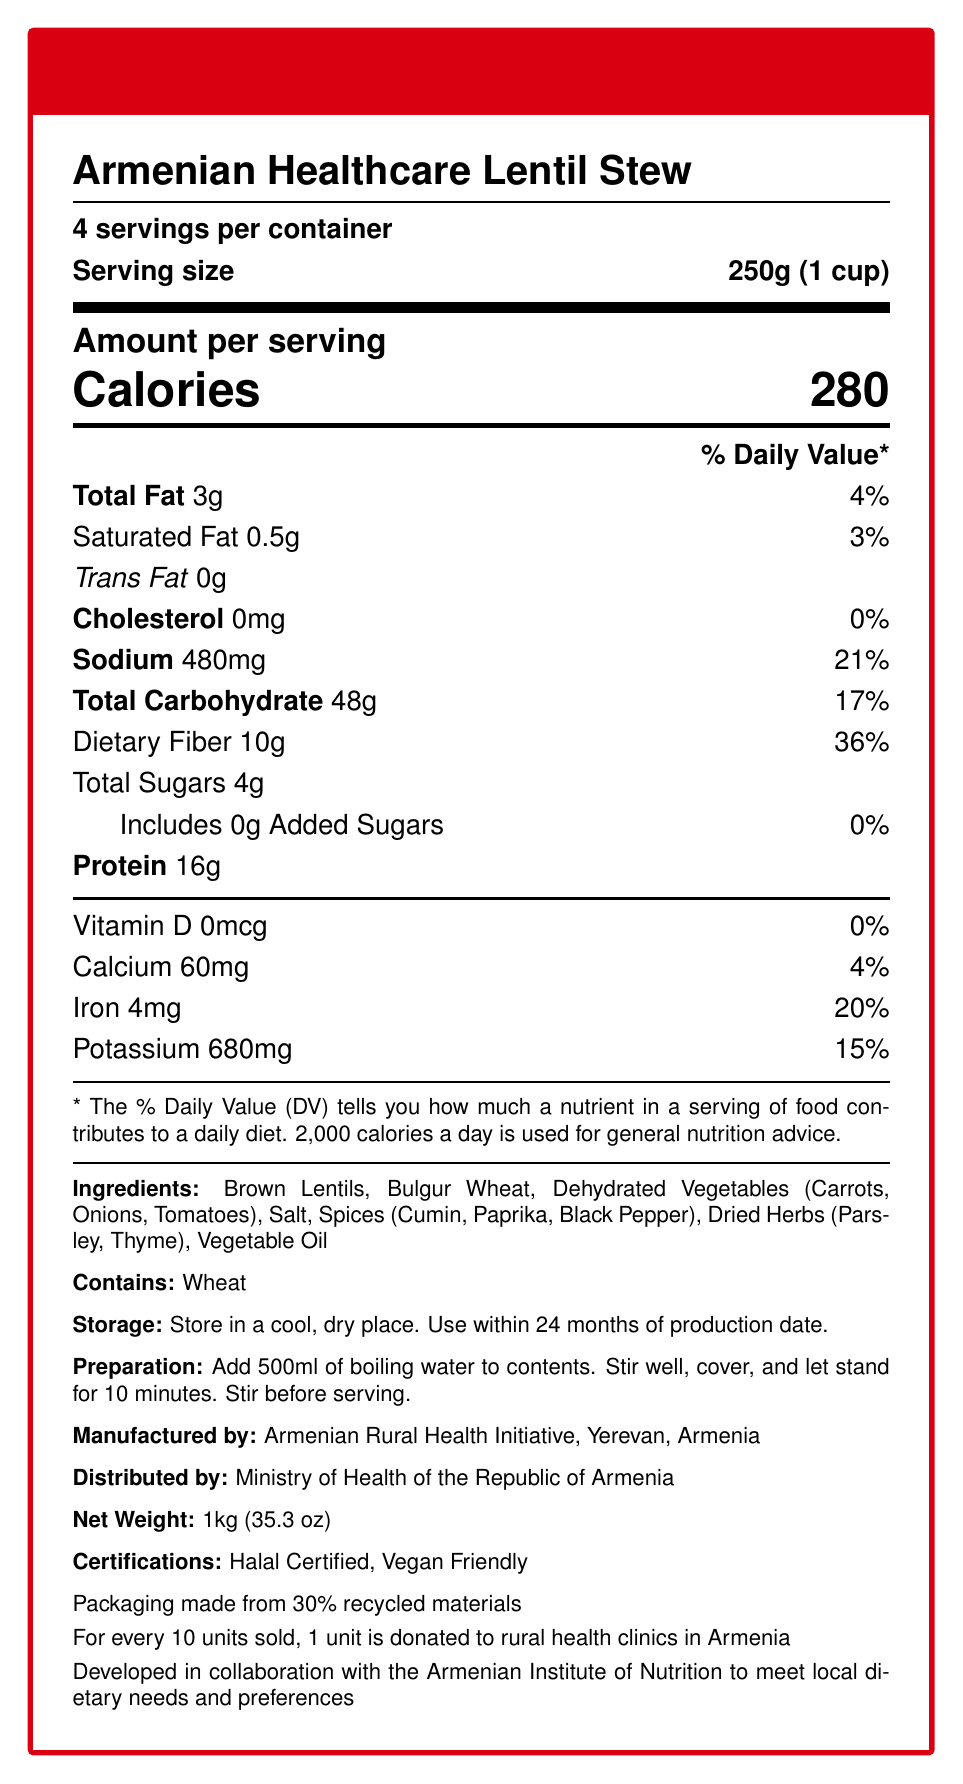what is the serving size? The serving size is specified as 250g, which is equivalent to 1 cup.
Answer: 250g (1 cup) how many servings are in a container? The document specifies that there are 4 servings per container.
Answer: 4 servings what is the amount of sodium per serving? The amount of sodium per serving is explicitly mentioned as 480mg.
Answer: 480mg how long should you let the meal stand after adding boiling water? The preparation instructions state to let the meal stand for 10 minutes after adding boiling water.
Answer: 10 minutes Is the Armenian Healthcare Lentil Stew certified vegan? The document lists "Vegan Friendly" under certifications.
Answer: Yes which ingredient is listed first? A. Bulgur Wheat B. Dehydrated Vegetables C. Brown Lentils D. Salt The ingredients list starts with "Brown Lentils".
Answer: C. Brown Lentils what percentage of the daily value for iron does one serving provide? The document notes that one serving provides 20% of the daily value for iron.
Answer: 20% how many grams of protein are there per serving? The protein content per serving is listed as 16g.
Answer: 16g what is the net weight of the product? The net weight of the product is given as 1kg or 35.3 oz.
Answer: 1kg (35.3 oz) what type of meal is the Armenian Healthcare Lentil Stew? The name of the product is "Armenian Healthcare Lentil Stew".
Answer: Lentil Stew what is the source of added sugars in the stew? The document mentions that the stew includes 0g of added sugars.
Answer: There are no added sugars is the packaging material environmentally friendly? The document states that the packaging is made from 30% recycled materials.
Answer: Yes how many calories are in a single serving? A. 180 B. 200 C. 280 D. 300 The calories per serving are explicitly listed as 280.
Answer: C. 280 is there any cholesterol in this product? The amount of cholesterol is listed as 0mg, indicating there is no cholesterol.
Answer: No what organization is responsible for distributing this product? The distributing organization is clearly noted as the Ministry of Health of the Republic of Armenia.
Answer: Ministry of Health of the Republic of Armenia how many grams of dietary fiber are there in one serving? The dietary fiber content per serving is listed as 10g.
Answer: 10g name one spice used in the Armenian Healthcare Lentil Stew. One of the spices listed is cumin.
Answer: Cumin can the document tell us how much Vitamin C is in the product? The document does not provide any information regarding Vitamin C content.
Answer: Cannot be determined summarize the main information provided in the document. The document primarily includes nutrition facts, ingredient details, certifications, and other product information designed to inform about the stew's nutritional benefits and suitability for rural healthcare distribution.
Answer: The document describes the nutrition facts and features of the Armenian Healthcare Lentil Stew. It highlights serving size, calorie content, and nutrient values, and provides details on ingredients, preparation, storage, and certifications. The product is vegan-friendly, includes no cholesterol, and is high in dietary fiber. Manufactured by the Armenian Rural Health Initiative, the meal option is suitable for distribution in rural healthcare facilities, supporting sustainability by using recycled packaging and providing donations for rural clinics. 